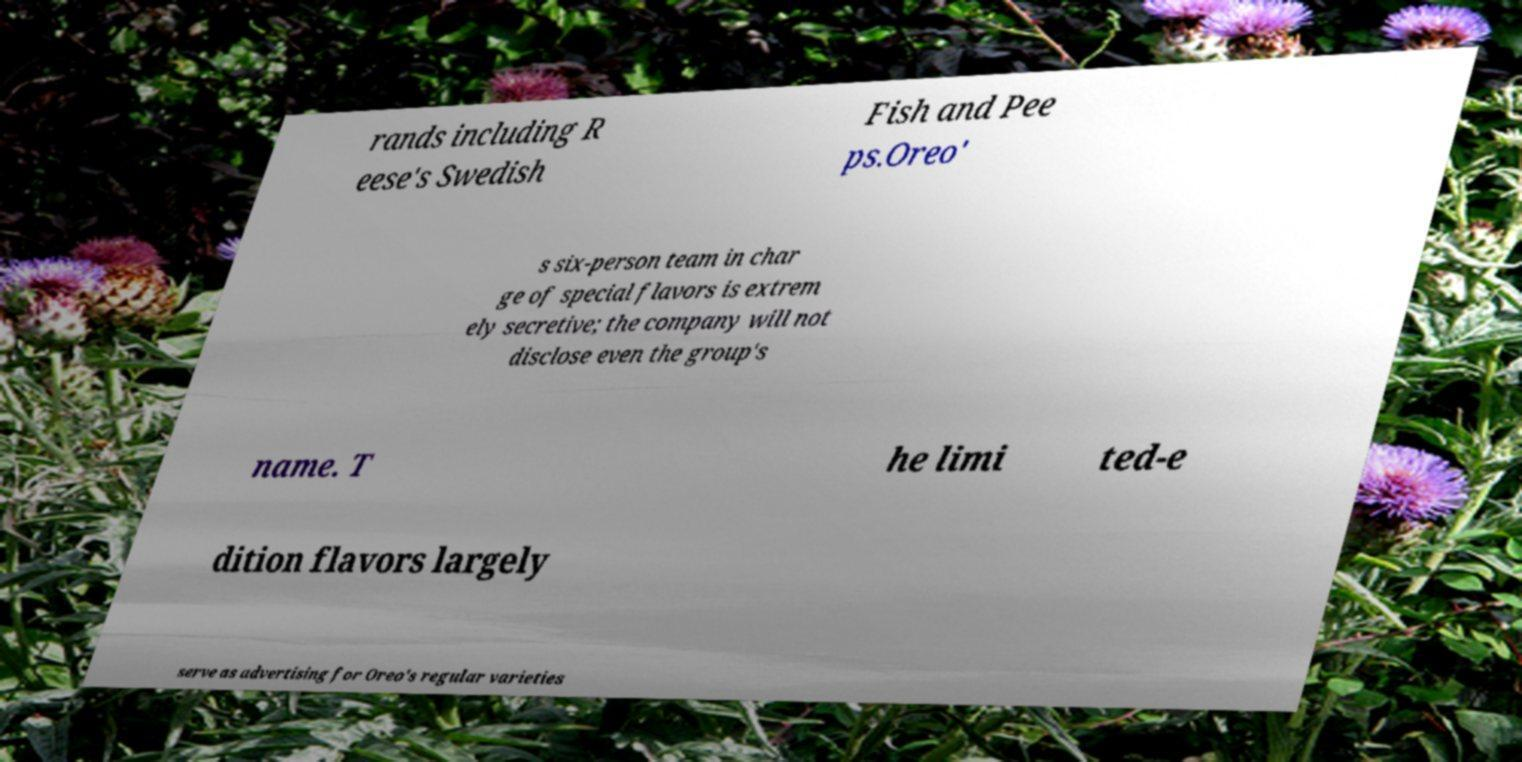There's text embedded in this image that I need extracted. Can you transcribe it verbatim? rands including R eese's Swedish Fish and Pee ps.Oreo' s six-person team in char ge of special flavors is extrem ely secretive; the company will not disclose even the group's name. T he limi ted-e dition flavors largely serve as advertising for Oreo's regular varieties 